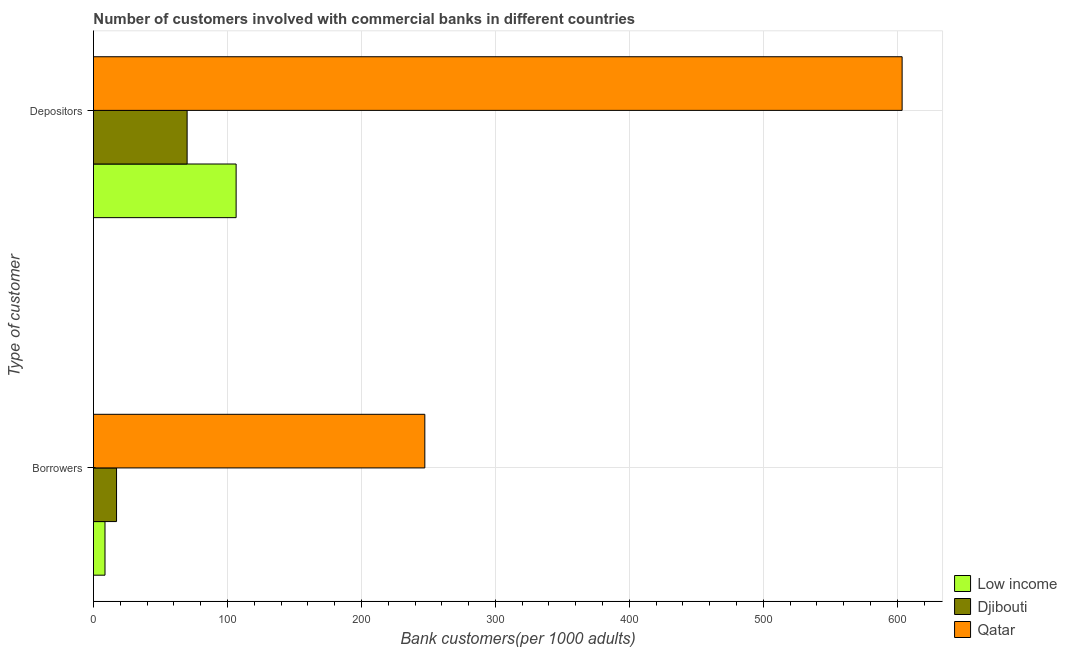How many different coloured bars are there?
Offer a very short reply. 3. How many groups of bars are there?
Offer a terse response. 2. What is the label of the 2nd group of bars from the top?
Give a very brief answer. Borrowers. What is the number of depositors in Qatar?
Provide a succinct answer. 603.57. Across all countries, what is the maximum number of borrowers?
Provide a short and direct response. 247.33. Across all countries, what is the minimum number of depositors?
Offer a very short reply. 69.91. In which country was the number of depositors maximum?
Provide a succinct answer. Qatar. In which country was the number of depositors minimum?
Offer a very short reply. Djibouti. What is the total number of depositors in the graph?
Provide a short and direct response. 779.97. What is the difference between the number of depositors in Djibouti and that in Low income?
Keep it short and to the point. -36.58. What is the difference between the number of depositors in Djibouti and the number of borrowers in Low income?
Your answer should be very brief. 61.29. What is the average number of depositors per country?
Your answer should be compact. 259.99. What is the difference between the number of borrowers and number of depositors in Djibouti?
Give a very brief answer. -52.68. What is the ratio of the number of borrowers in Qatar to that in Djibouti?
Keep it short and to the point. 14.35. Is the number of depositors in Qatar less than that in Djibouti?
Make the answer very short. No. What does the 2nd bar from the top in Borrowers represents?
Offer a terse response. Djibouti. What does the 1st bar from the bottom in Borrowers represents?
Provide a short and direct response. Low income. How many countries are there in the graph?
Offer a terse response. 3. Does the graph contain any zero values?
Give a very brief answer. No. Where does the legend appear in the graph?
Give a very brief answer. Bottom right. How are the legend labels stacked?
Ensure brevity in your answer.  Vertical. What is the title of the graph?
Your response must be concise. Number of customers involved with commercial banks in different countries. Does "Sao Tome and Principe" appear as one of the legend labels in the graph?
Give a very brief answer. No. What is the label or title of the X-axis?
Give a very brief answer. Bank customers(per 1000 adults). What is the label or title of the Y-axis?
Provide a short and direct response. Type of customer. What is the Bank customers(per 1000 adults) in Low income in Borrowers?
Offer a terse response. 8.62. What is the Bank customers(per 1000 adults) in Djibouti in Borrowers?
Offer a very short reply. 17.23. What is the Bank customers(per 1000 adults) of Qatar in Borrowers?
Your answer should be compact. 247.33. What is the Bank customers(per 1000 adults) of Low income in Depositors?
Provide a short and direct response. 106.49. What is the Bank customers(per 1000 adults) of Djibouti in Depositors?
Your response must be concise. 69.91. What is the Bank customers(per 1000 adults) in Qatar in Depositors?
Your answer should be very brief. 603.57. Across all Type of customer, what is the maximum Bank customers(per 1000 adults) in Low income?
Ensure brevity in your answer.  106.49. Across all Type of customer, what is the maximum Bank customers(per 1000 adults) in Djibouti?
Offer a very short reply. 69.91. Across all Type of customer, what is the maximum Bank customers(per 1000 adults) of Qatar?
Keep it short and to the point. 603.57. Across all Type of customer, what is the minimum Bank customers(per 1000 adults) in Low income?
Offer a terse response. 8.62. Across all Type of customer, what is the minimum Bank customers(per 1000 adults) in Djibouti?
Ensure brevity in your answer.  17.23. Across all Type of customer, what is the minimum Bank customers(per 1000 adults) of Qatar?
Offer a terse response. 247.33. What is the total Bank customers(per 1000 adults) of Low income in the graph?
Your response must be concise. 115.11. What is the total Bank customers(per 1000 adults) in Djibouti in the graph?
Offer a terse response. 87.14. What is the total Bank customers(per 1000 adults) in Qatar in the graph?
Your answer should be compact. 850.9. What is the difference between the Bank customers(per 1000 adults) of Low income in Borrowers and that in Depositors?
Make the answer very short. -97.87. What is the difference between the Bank customers(per 1000 adults) in Djibouti in Borrowers and that in Depositors?
Your response must be concise. -52.68. What is the difference between the Bank customers(per 1000 adults) of Qatar in Borrowers and that in Depositors?
Provide a short and direct response. -356.24. What is the difference between the Bank customers(per 1000 adults) in Low income in Borrowers and the Bank customers(per 1000 adults) in Djibouti in Depositors?
Provide a short and direct response. -61.29. What is the difference between the Bank customers(per 1000 adults) of Low income in Borrowers and the Bank customers(per 1000 adults) of Qatar in Depositors?
Offer a very short reply. -594.95. What is the difference between the Bank customers(per 1000 adults) of Djibouti in Borrowers and the Bank customers(per 1000 adults) of Qatar in Depositors?
Provide a succinct answer. -586.34. What is the average Bank customers(per 1000 adults) in Low income per Type of customer?
Offer a terse response. 57.56. What is the average Bank customers(per 1000 adults) in Djibouti per Type of customer?
Provide a succinct answer. 43.57. What is the average Bank customers(per 1000 adults) of Qatar per Type of customer?
Keep it short and to the point. 425.45. What is the difference between the Bank customers(per 1000 adults) in Low income and Bank customers(per 1000 adults) in Djibouti in Borrowers?
Your answer should be very brief. -8.61. What is the difference between the Bank customers(per 1000 adults) in Low income and Bank customers(per 1000 adults) in Qatar in Borrowers?
Offer a very short reply. -238.71. What is the difference between the Bank customers(per 1000 adults) of Djibouti and Bank customers(per 1000 adults) of Qatar in Borrowers?
Provide a short and direct response. -230.09. What is the difference between the Bank customers(per 1000 adults) of Low income and Bank customers(per 1000 adults) of Djibouti in Depositors?
Offer a terse response. 36.58. What is the difference between the Bank customers(per 1000 adults) of Low income and Bank customers(per 1000 adults) of Qatar in Depositors?
Provide a short and direct response. -497.08. What is the difference between the Bank customers(per 1000 adults) of Djibouti and Bank customers(per 1000 adults) of Qatar in Depositors?
Offer a terse response. -533.66. What is the ratio of the Bank customers(per 1000 adults) in Low income in Borrowers to that in Depositors?
Provide a succinct answer. 0.08. What is the ratio of the Bank customers(per 1000 adults) of Djibouti in Borrowers to that in Depositors?
Your response must be concise. 0.25. What is the ratio of the Bank customers(per 1000 adults) of Qatar in Borrowers to that in Depositors?
Ensure brevity in your answer.  0.41. What is the difference between the highest and the second highest Bank customers(per 1000 adults) of Low income?
Offer a very short reply. 97.87. What is the difference between the highest and the second highest Bank customers(per 1000 adults) in Djibouti?
Provide a short and direct response. 52.68. What is the difference between the highest and the second highest Bank customers(per 1000 adults) of Qatar?
Keep it short and to the point. 356.24. What is the difference between the highest and the lowest Bank customers(per 1000 adults) in Low income?
Keep it short and to the point. 97.87. What is the difference between the highest and the lowest Bank customers(per 1000 adults) in Djibouti?
Your answer should be compact. 52.68. What is the difference between the highest and the lowest Bank customers(per 1000 adults) of Qatar?
Give a very brief answer. 356.24. 